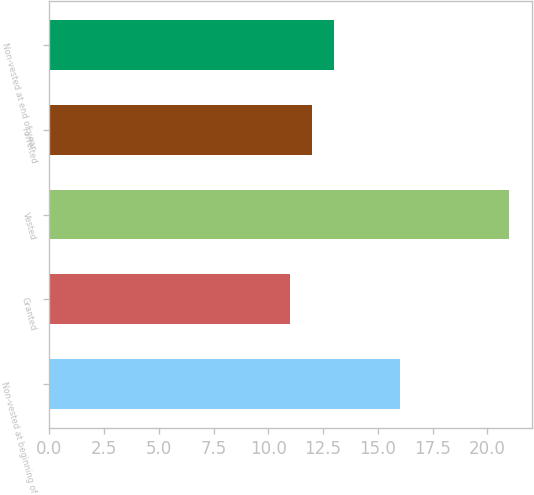<chart> <loc_0><loc_0><loc_500><loc_500><bar_chart><fcel>Non-vested at beginning of<fcel>Granted<fcel>Vested<fcel>Forfeited<fcel>Non-vested at end of year<nl><fcel>16<fcel>11<fcel>21<fcel>12<fcel>13<nl></chart> 